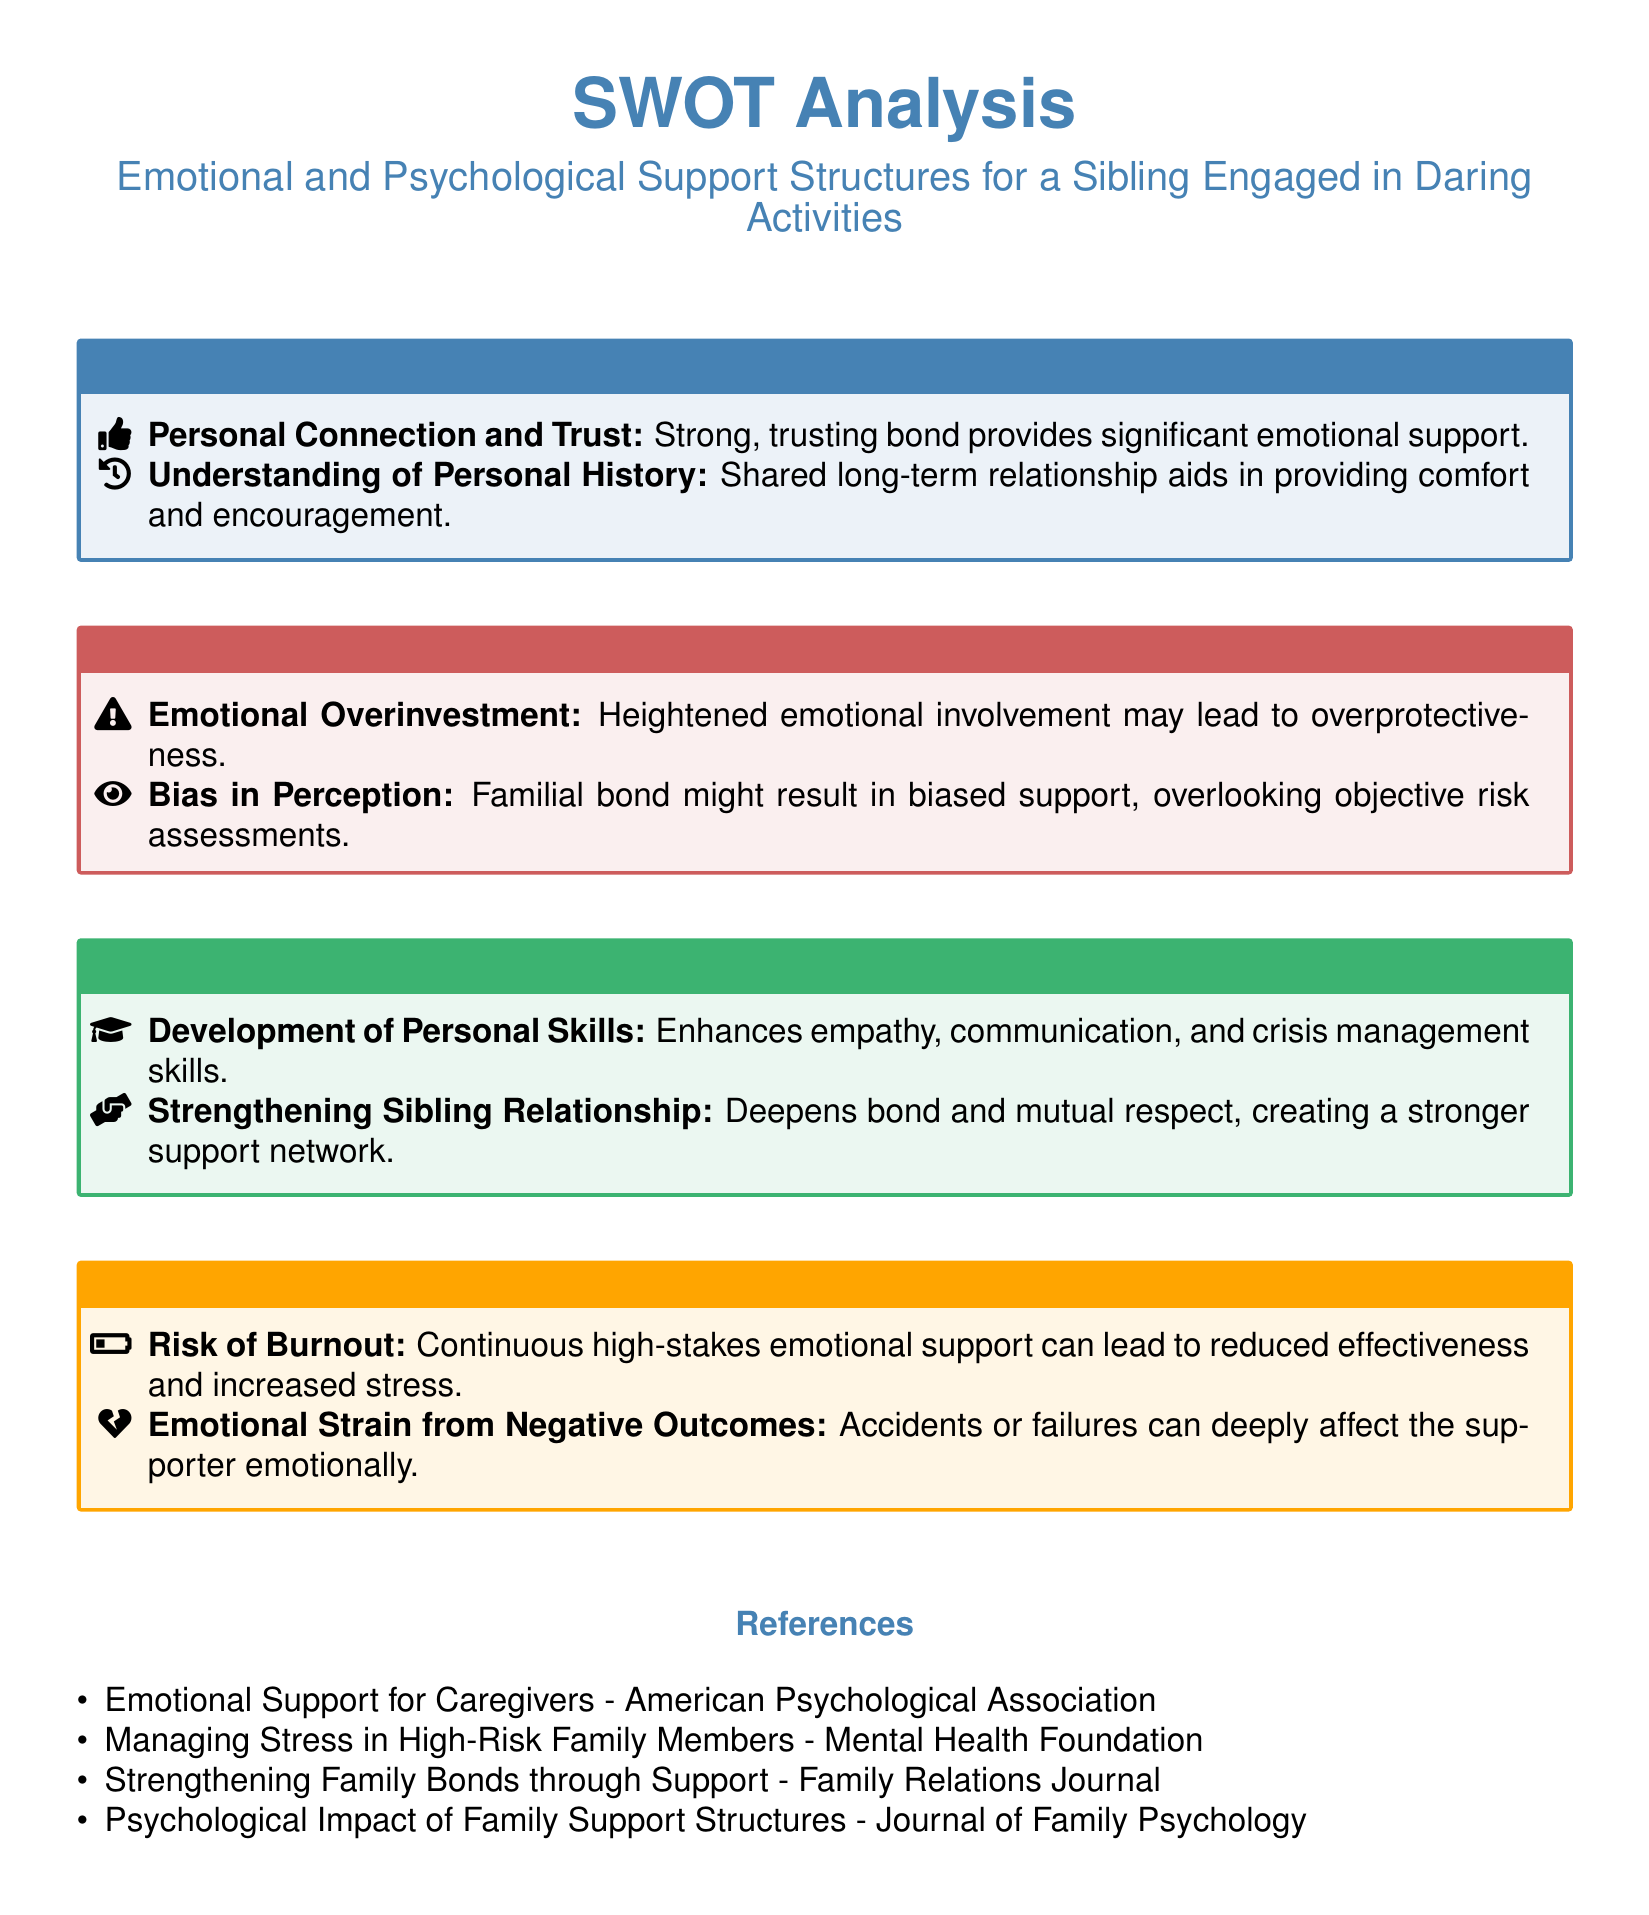What are the strengths listed in the SWOT analysis? The strengths identified include personal connection and trust, and understanding of personal history.
Answer: Personal Connection and Trust; Understanding of Personal History What does the SWOT analysis identify as a weakness? The analysis highlights emotional overinvestment and bias in perception as weaknesses.
Answer: Emotional Overinvestment; Bias in Perception What opportunities does the document suggest for support structures? The opportunities mentioned are development of personal skills and strengthening sibling relationship.
Answer: Development of Personal Skills; Strengthening Sibling Relationship What is one threat associated with providing emotional support? The document lists risk of burnout and emotional strain from negative outcomes as threats.
Answer: Risk of Burnout; Emotional Strain from Negative Outcomes How many strengths are identified in the document? The document outlines two strengths in total.
Answer: 2 What is the color associated with weaknesses in the SWOT analysis? The SWOT analysis uses red to denote weaknesses.
Answer: Red What type of document is this? This document is a SWOT analysis focusing on emotional and psychological support structures.
Answer: SWOT Analysis What are the two components of 'Opportunities' mentioned? The two components are development of personal skills and strengthening sibling relationship.
Answer: Development of Personal Skills; Strengthening Sibling Relationship 